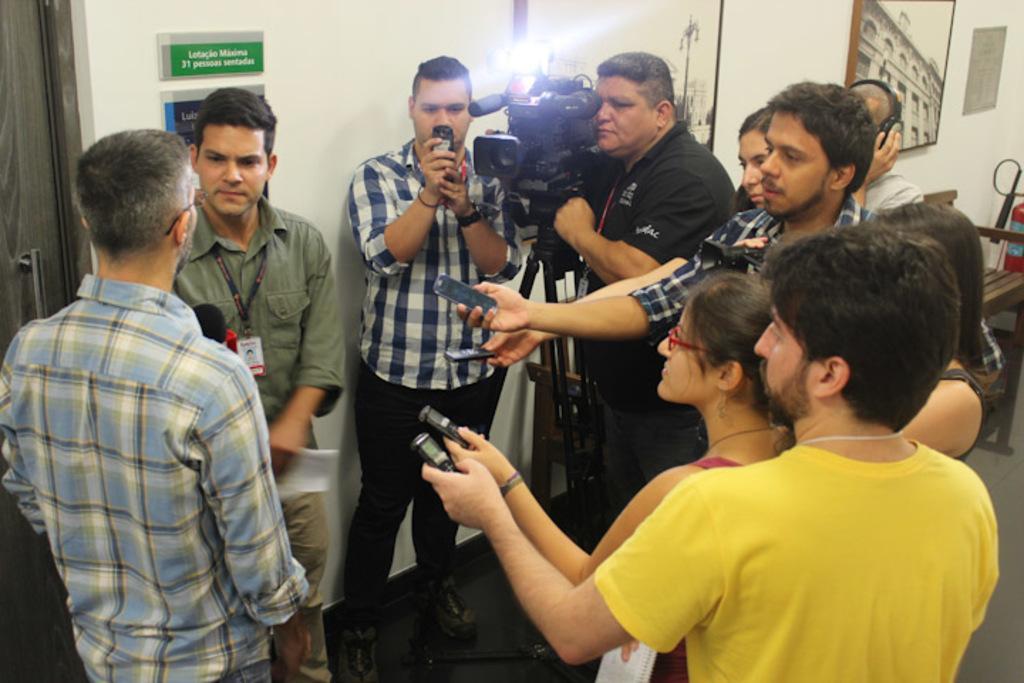How would you summarize this image in a sentence or two? In the middle a camera man is shooting. On the left side a man is standing and speaking into microphone. In the right side a boy is standing, he wore a yellow color t-shirt. There is a girl in front of him. 